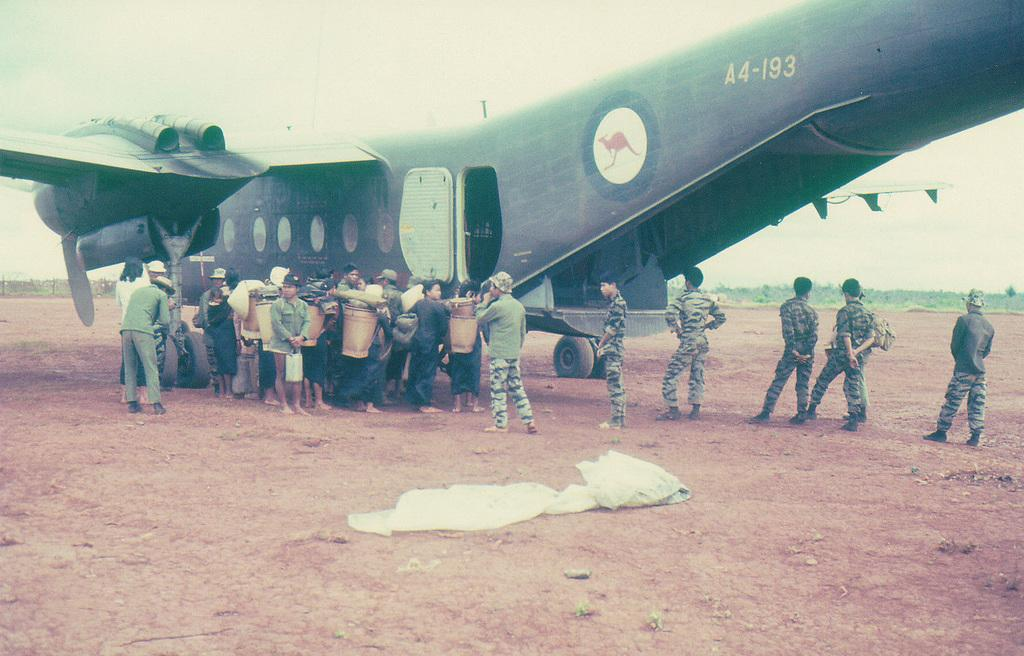What is the main subject of the image? The main subject of the image is an airplane. What features can be seen on the airplane? The airplane has a door and windows. What are the people near the airplane doing? There are groups of people standing near the airplane, and some of them are holding buckets. What else is visible in the image? There is a cloth visible in the image. How many grandfathers are present in the image? There is no mention of a grandfather in the image, so it is impossible to determine the number of grandfathers present. What are the boys doing in the image? There is no mention of boys in the image, so it is impossible to determine what they might be doing. 